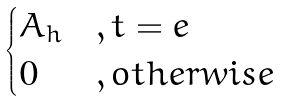Convert formula to latex. <formula><loc_0><loc_0><loc_500><loc_500>\begin{cases} A _ { h } & , t = e \\ 0 & , o t h e r w i s e \end{cases}</formula> 